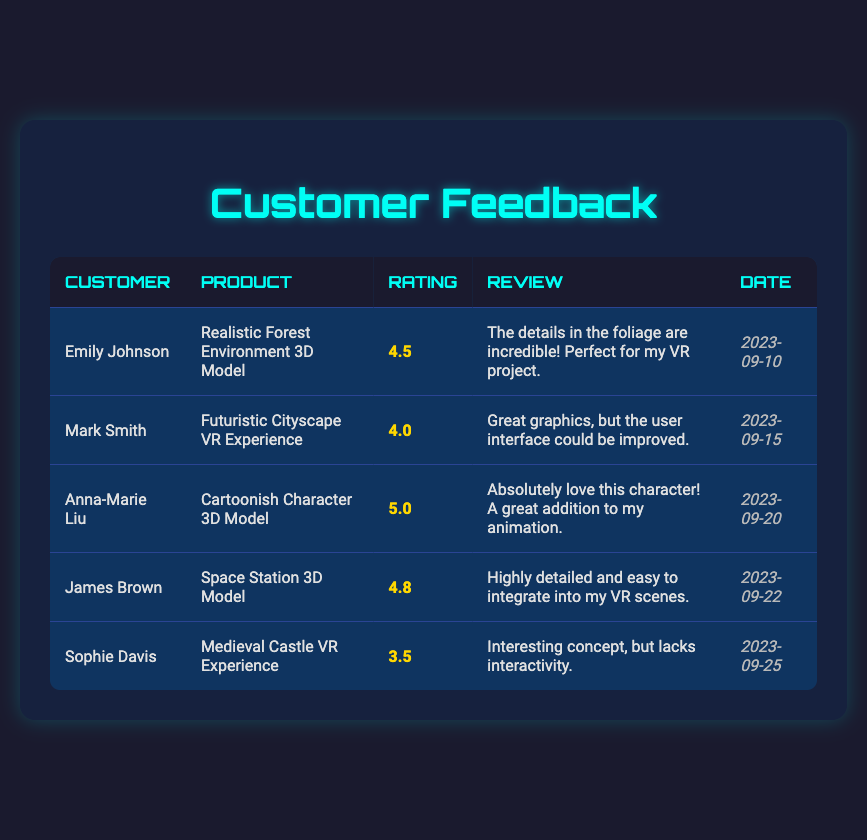What is the highest rating received by a product? The ratings in the table are 4.5, 4.0, 5.0, 4.8, and 3.5. Among these, the highest rating is 5.0, which corresponds to the "Cartoonish Character 3D Model" reviewed by Anna-Marie Liu.
Answer: 5.0 Which product received the lowest rating? By examining the ratings, 4.5, 4.0, 5.0, 4.8, and 3.5, the lowest rating is 3.5. This rating belongs to the "Medieval Castle VR Experience" reviewed by Sophie Davis.
Answer: Medieval Castle VR Experience How many customers gave a rating of 4.0 or higher? The ratings of 4.5, 4.0, 5.0, and 4.8 are 4.0 or higher. There are 4 customers associated with these ratings—Emily Johnson, Mark Smith, Anna-Marie Liu, and James Brown.
Answer: 4 What is the average rating of all products reviewed? Adding up the ratings: (4.5 + 4.0 + 5.0 + 4.8 + 3.5) = 22.8. There are 5 ratings in total, so to find the average, divide the sum by 5: 22.8 / 5 = 4.56.
Answer: 4.56 Did any customer give a perfect rating? A perfect rating would be 5.0. In the table, Anna-Marie Liu rated the "Cartoonish Character 3D Model" with a score of 5.0. Therefore, the answer is yes.
Answer: Yes Which product has the most recent review? The date of the reviews are September 10, 15, 20, 22, and 25, 2023. The most recent date is September 25, 2023, from Sophie Davis who reviewed the "Medieval Castle VR Experience."
Answer: Medieval Castle VR Experience What rating did Mark Smith give his product? Mark Smith provided a rating of 4.0 for the "Futuristic Cityscape VR Experience" based on the information specified in the table.
Answer: 4.0 How many reviews mention the need for improved interactivity? The feedback from Sophie Davis mentioned a lack of interactivity, while all other reviews are positively framed without mentioning interactivity issues. Therefore, there’s only one review that indicates this need.
Answer: 1 Which customer gave a review mentioning graphics? Mark Smith noted in his review, "Great graphics, but the user interface could be improved," indicating he referred to graphics in relation to his product.
Answer: Mark Smith 